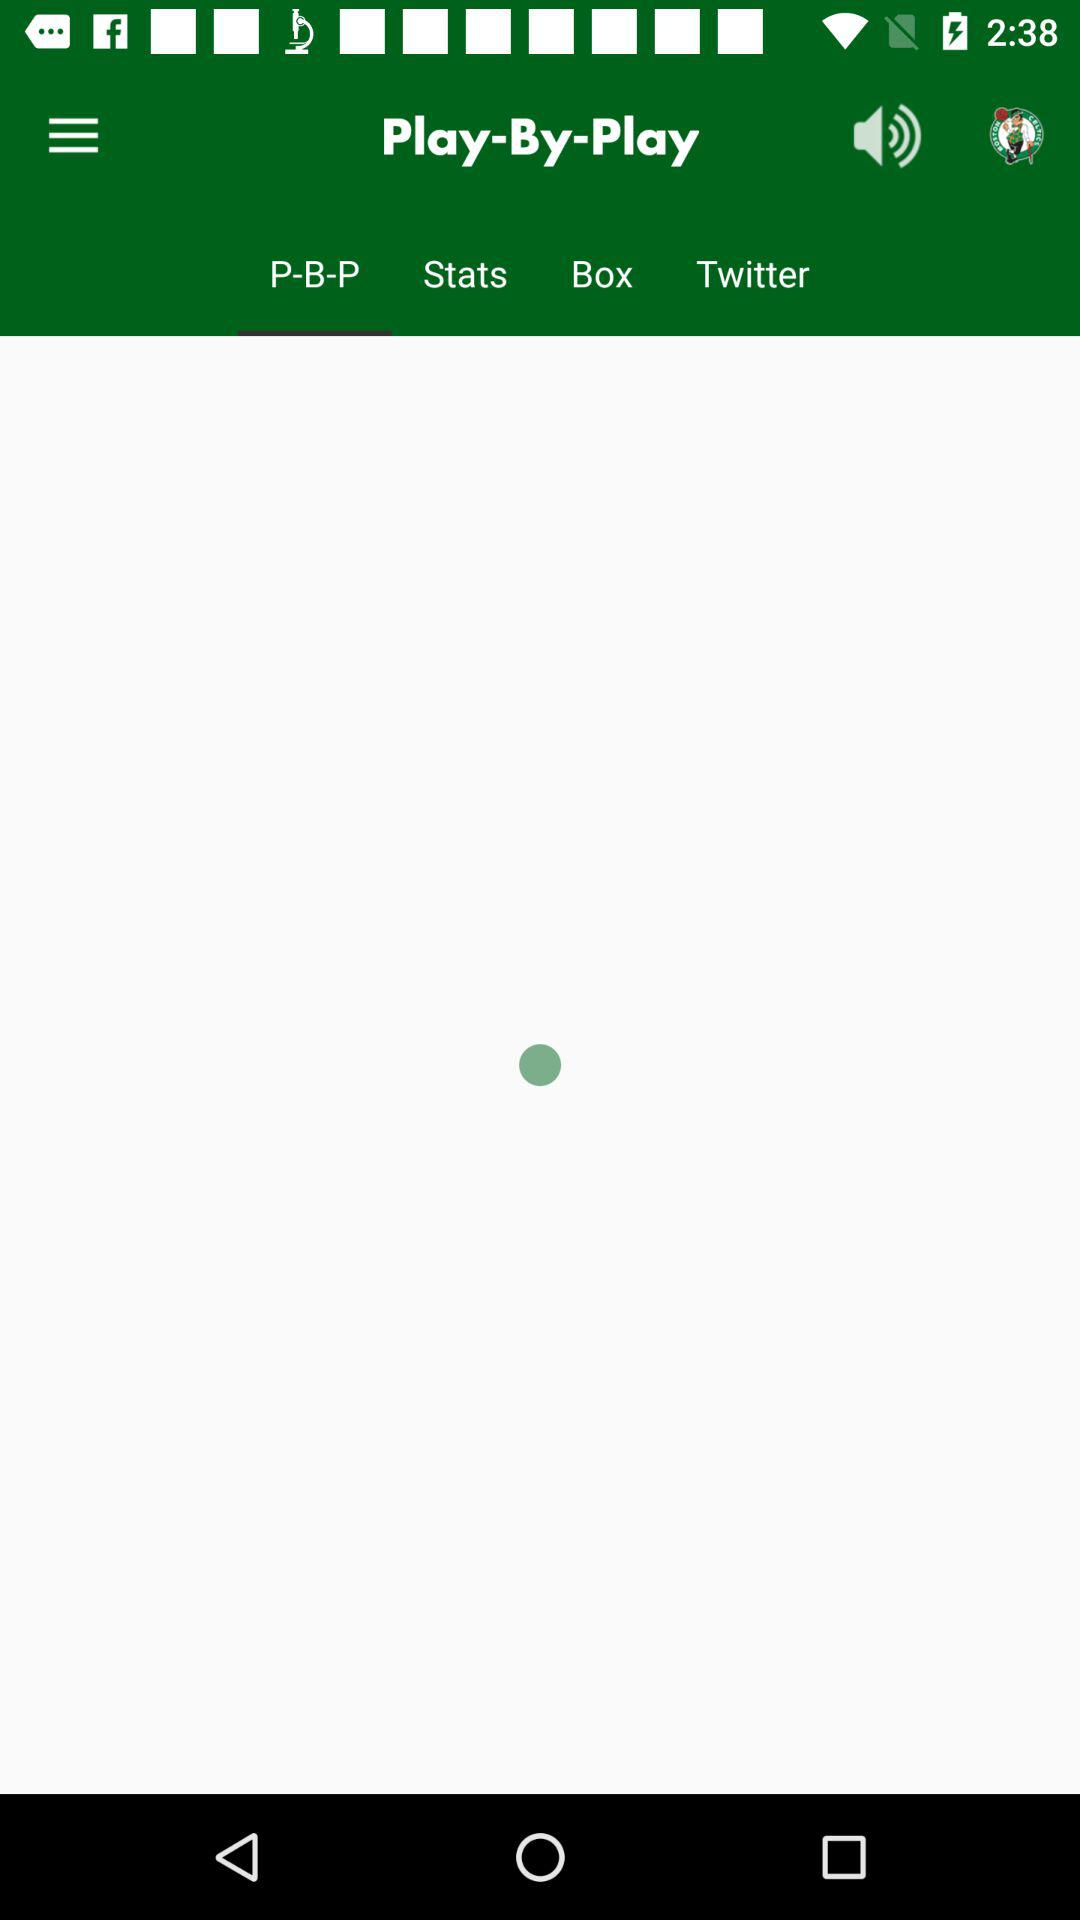Which tab is selected? The selected tab is "P-B-P". 